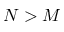<formula> <loc_0><loc_0><loc_500><loc_500>N > M</formula> 